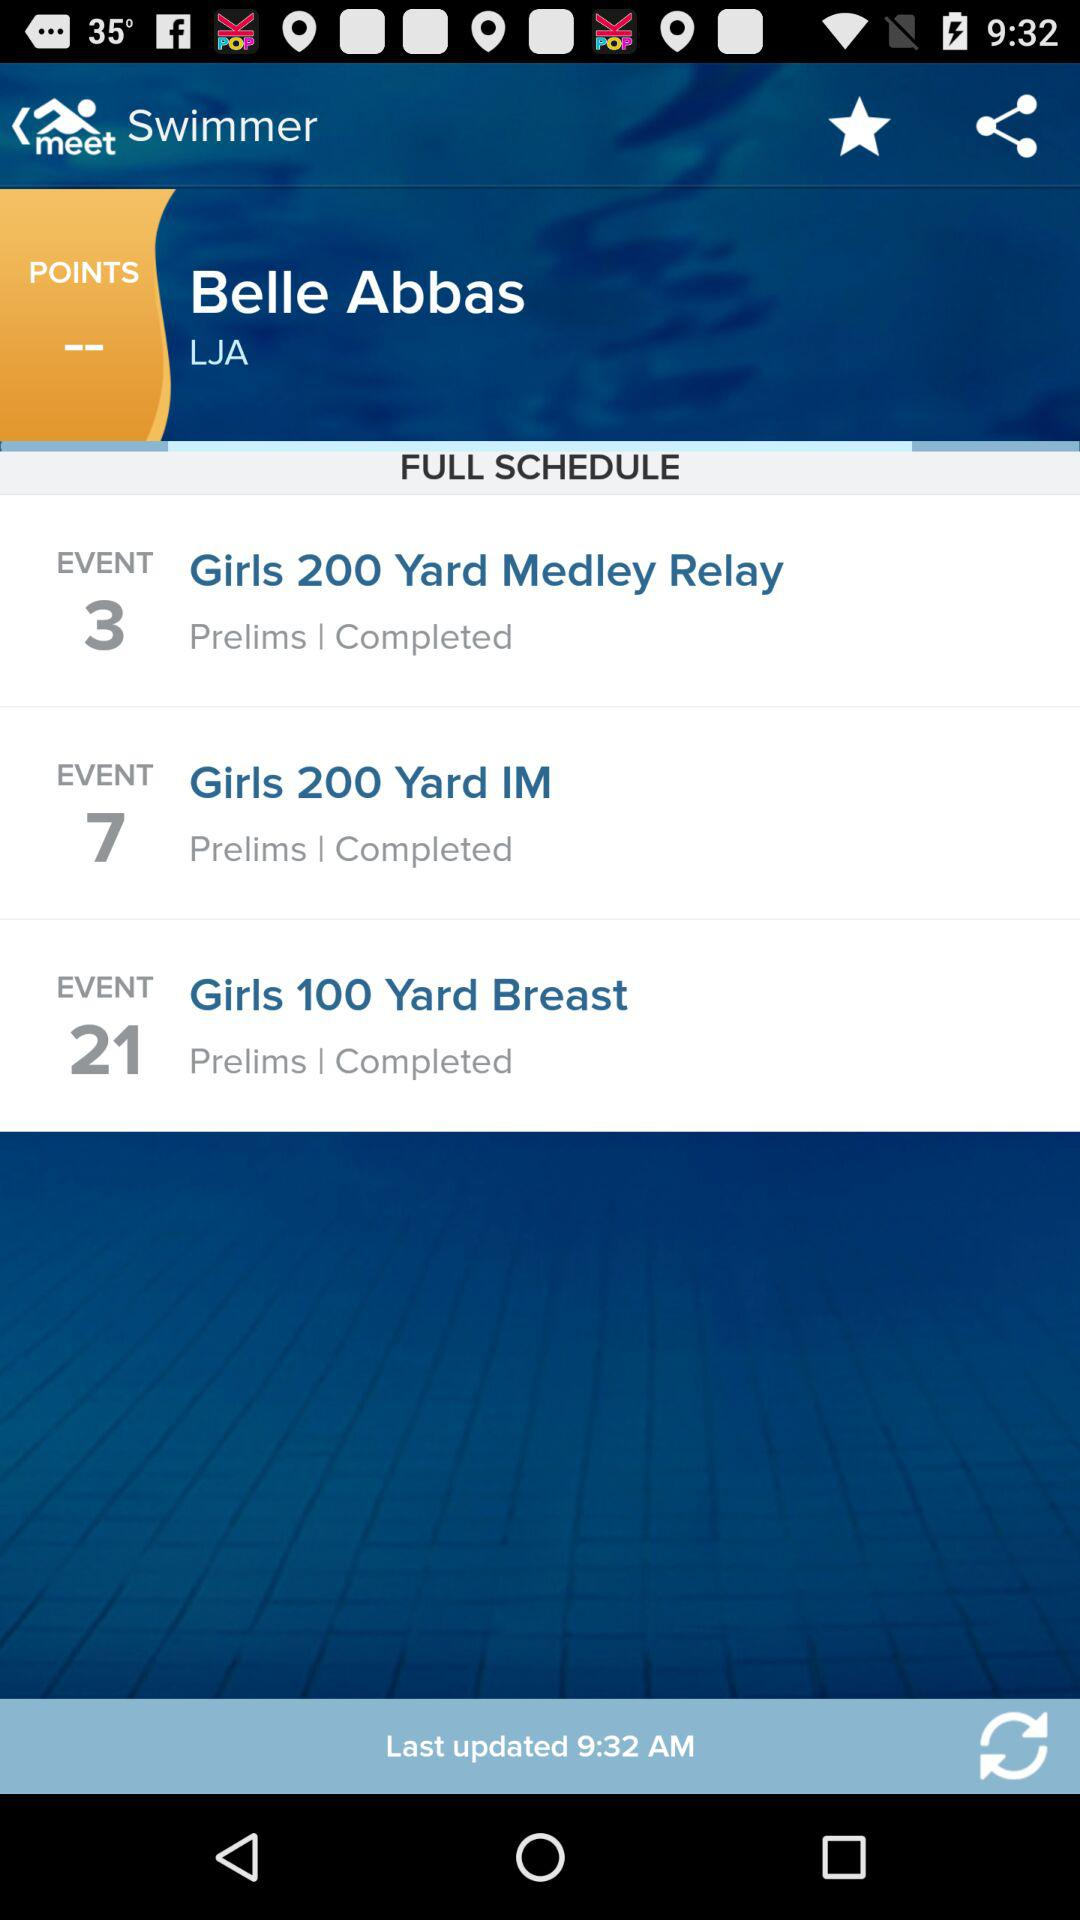Who is shown in event 21?
When the provided information is insufficient, respond with <no answer>. <no answer> 